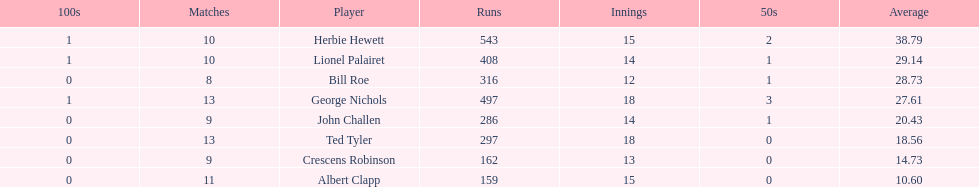How many more runs does john have than albert? 127. 